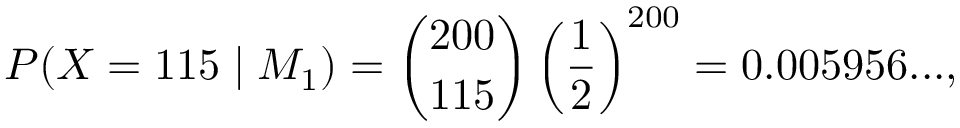<formula> <loc_0><loc_0><loc_500><loc_500>P ( X = 1 1 5 | M _ { 1 } ) = { \binom { 2 0 0 } { 1 1 5 } } \left ( { \frac { 1 } { 2 } } \right ) ^ { 2 0 0 } = 0 . 0 0 5 9 5 6 \dots ,</formula> 